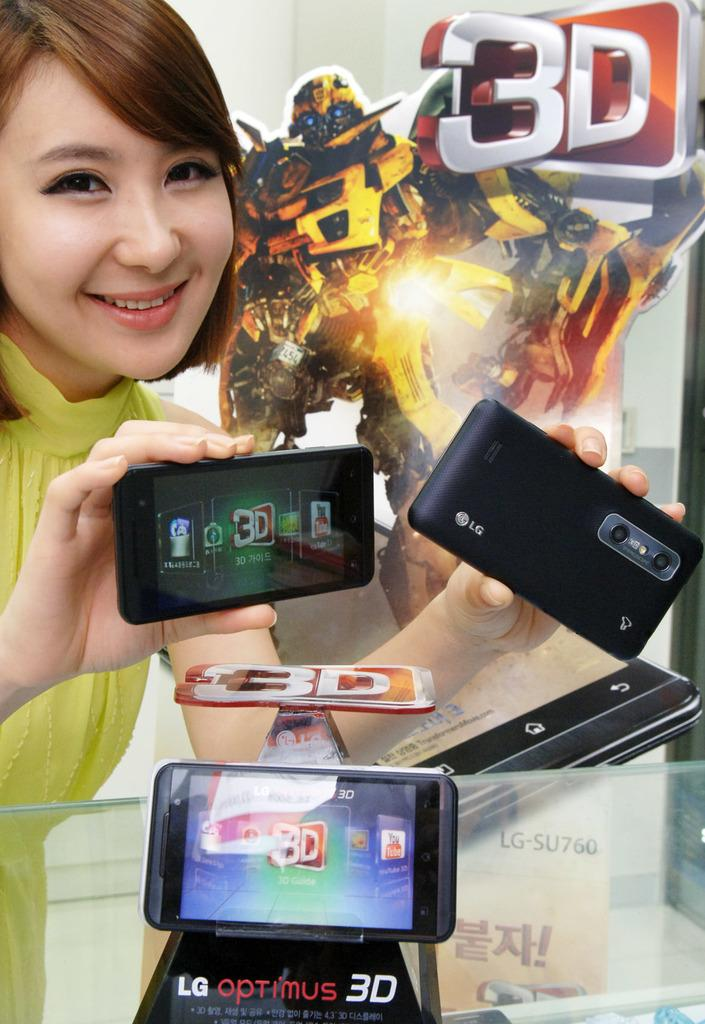What is the lady in the image doing? The lady is standing and holding mobiles in the image. What else can be seen in the image besides the lady? There is a mobile placed on a stand, a table, and a board in the background of the image. What might the lady be using to display the mobiles? The lady might be using the table to display the mobiles. What is the purpose of the board in the background? The purpose of the board in the background is not clear from the given facts. What type of linen is being used to cover the trains in the image? There are no trains or linen present in the image. How does the growth of the plants affect the display of mobiles in the image? There are no plants or growth mentioned in the image, so it cannot affect the display of mobiles. 